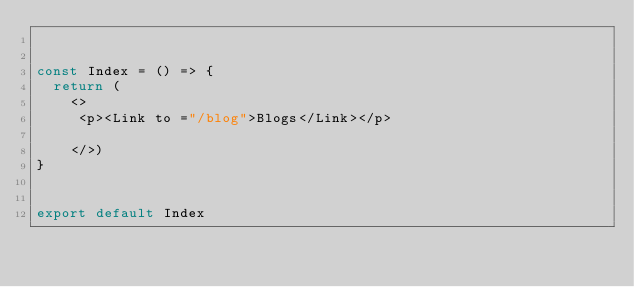<code> <loc_0><loc_0><loc_500><loc_500><_JavaScript_>

const Index = () => {
  return (
    <>
     <p><Link to ="/blog">Blogs</Link></p>
      
    </>)
}


export default Index</code> 